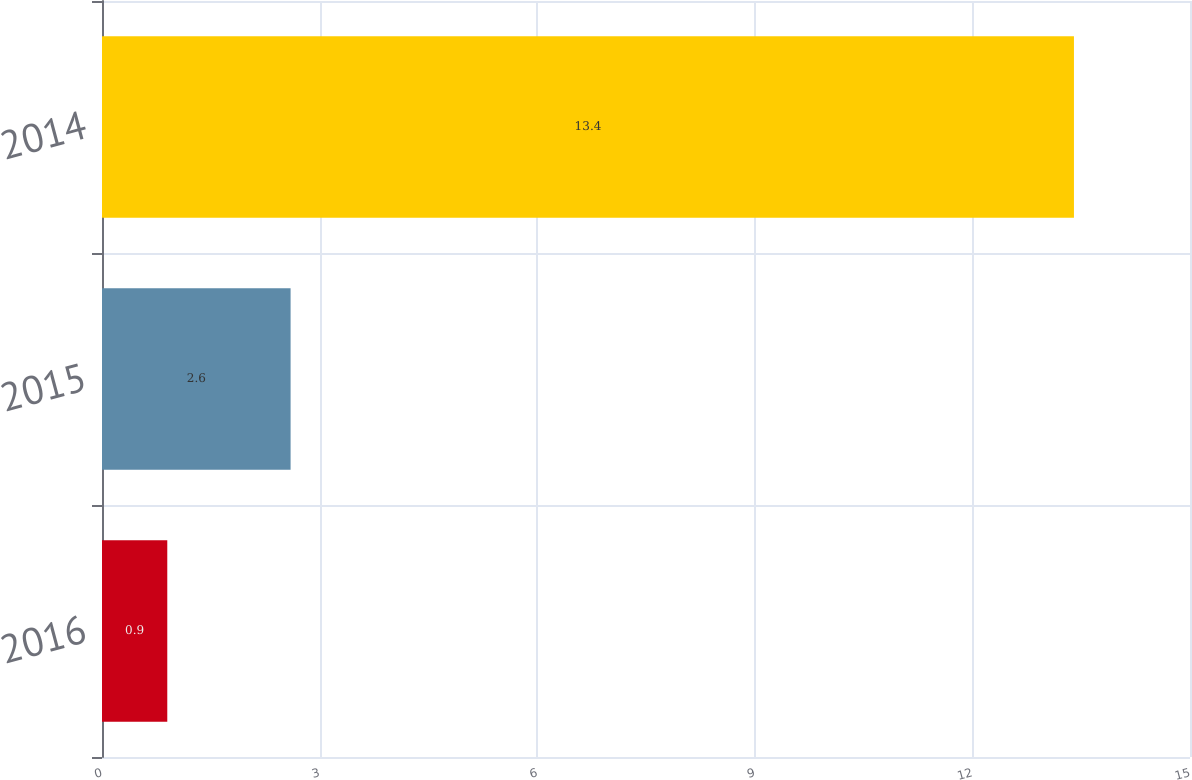Convert chart. <chart><loc_0><loc_0><loc_500><loc_500><bar_chart><fcel>2016<fcel>2015<fcel>2014<nl><fcel>0.9<fcel>2.6<fcel>13.4<nl></chart> 